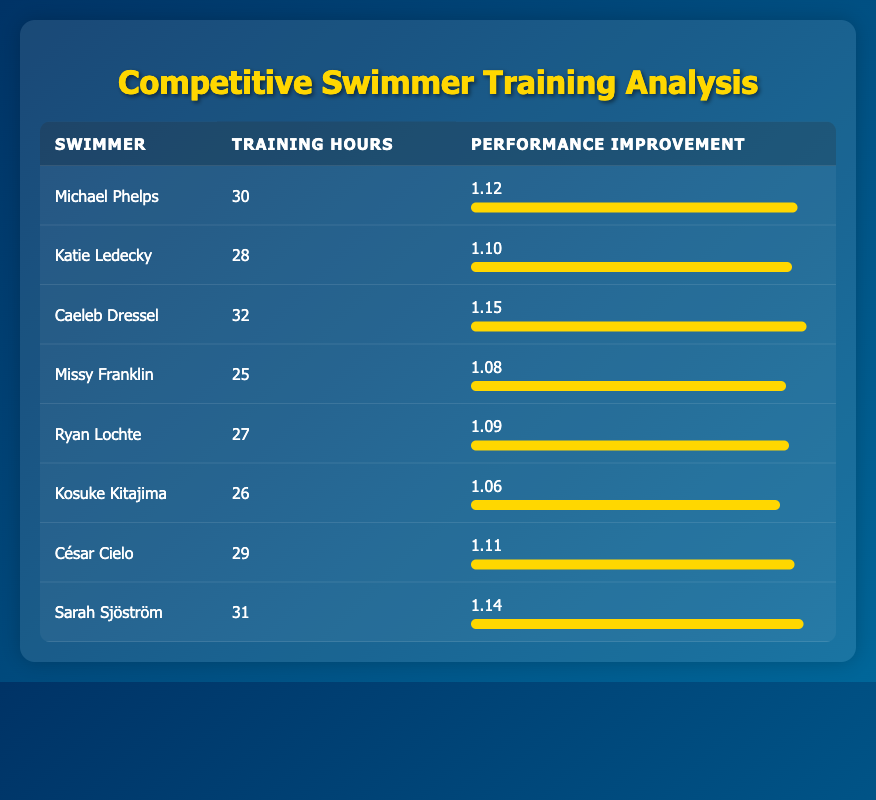What is the training hour count for Sarah Sjöström? In the table, locate Sarah Sjöström in the row provided. The "Training Hours" column shows 31 for her.
Answer: 31 Who had the highest performance improvement? By looking at the "Performance Improvement" column, we can see the highest value is 1.15, which corresponds to Caeleb Dressel.
Answer: Caeleb Dressel What is the average training hours for the swimmers listed? To find the average training hours, sum all training hours: 30 + 28 + 32 + 25 + 27 + 26 + 29 + 31 = 258. Then divide by the total number of swimmers, which is 8. The average is 258/8 = 32.25.
Answer: 32.25 Is Ryan Lochte’s performance improvement higher than Katie Ledecky's? Ryan Lochte has a performance improvement of 1.09 and Katie Ledecky has 1.10. Since 1.09 is less than 1.10, the statement is false.
Answer: No What is the difference between the highest and lowest performance improvements? The highest performance improvement is 1.15 (Caeleb Dressel) and the lowest is 1.06 (Kosuke Kitajima). The difference is 1.15 - 1.06 = 0.09.
Answer: 0.09 Which swimmer has the lowest training hours, and what is their performance improvement? By checking the "Training Hours" column, we see that Missy Franklin has the lowest hours at 25. Her performance improvement, from the same row, is 1.08.
Answer: Missy Franklin, 1.08 What is the median number of training hours for the group of swimmers? To get the median, list the training hours in order: 25, 26, 27, 28, 29, 30, 31, 32. Since there are 8 values, the median will be the average of the 4th and 5th values: (28 + 29) / 2 = 28.5.
Answer: 28.5 How many swimmers trained for more than 30 hours? From the table, we can count the swimmers whose training hours exceed 30: that's Caeleb Dressel (32), Sarah Sjöström (31), totaling 2 swimmers.
Answer: 2 What percentage increase in performance improvement does Sarah Sjöström have compared to Kosuke Kitajima? Sarah Sjöström has 1.14 and Kosuke Kitajima has 1.06. The percentage increase is calculated as: ((1.14 - 1.06) / 1.06) * 100 = 7.55%.
Answer: 7.55% 